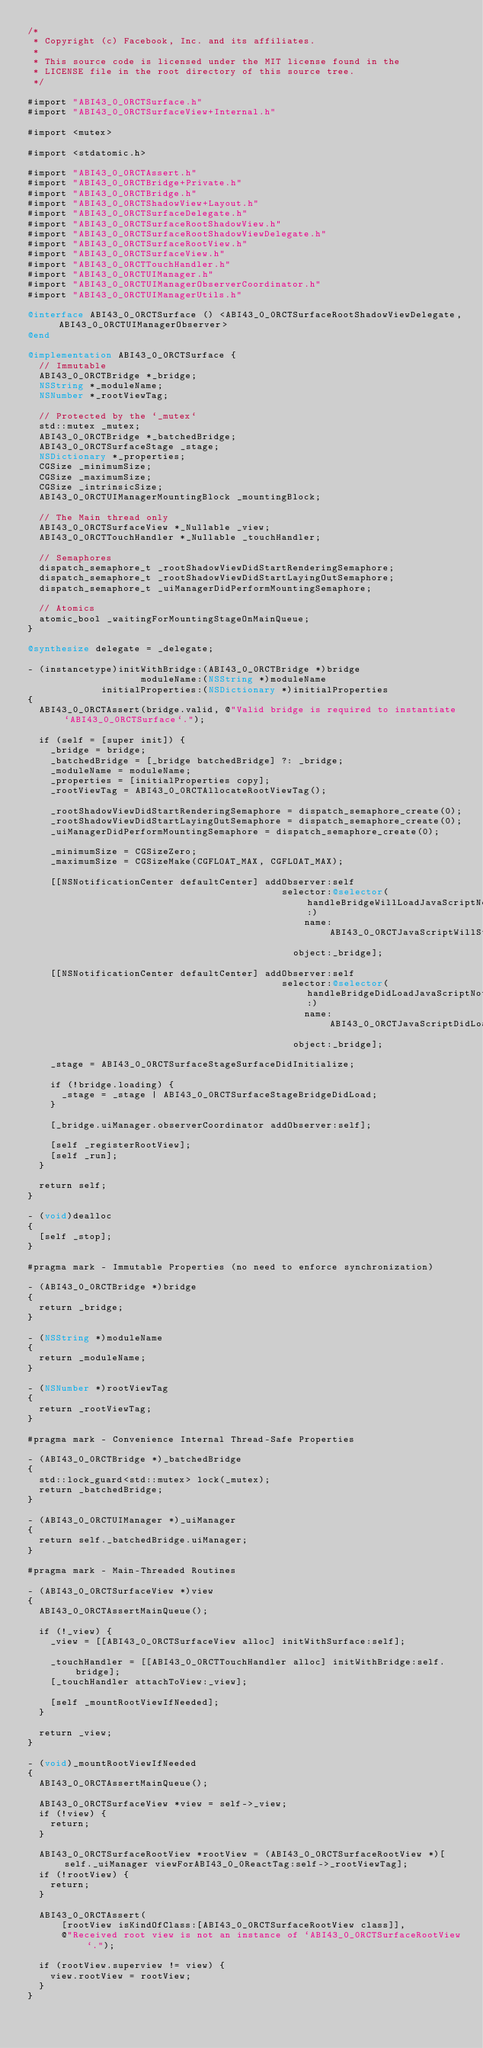Convert code to text. <code><loc_0><loc_0><loc_500><loc_500><_ObjectiveC_>/*
 * Copyright (c) Facebook, Inc. and its affiliates.
 *
 * This source code is licensed under the MIT license found in the
 * LICENSE file in the root directory of this source tree.
 */

#import "ABI43_0_0RCTSurface.h"
#import "ABI43_0_0RCTSurfaceView+Internal.h"

#import <mutex>

#import <stdatomic.h>

#import "ABI43_0_0RCTAssert.h"
#import "ABI43_0_0RCTBridge+Private.h"
#import "ABI43_0_0RCTBridge.h"
#import "ABI43_0_0RCTShadowView+Layout.h"
#import "ABI43_0_0RCTSurfaceDelegate.h"
#import "ABI43_0_0RCTSurfaceRootShadowView.h"
#import "ABI43_0_0RCTSurfaceRootShadowViewDelegate.h"
#import "ABI43_0_0RCTSurfaceRootView.h"
#import "ABI43_0_0RCTSurfaceView.h"
#import "ABI43_0_0RCTTouchHandler.h"
#import "ABI43_0_0RCTUIManager.h"
#import "ABI43_0_0RCTUIManagerObserverCoordinator.h"
#import "ABI43_0_0RCTUIManagerUtils.h"

@interface ABI43_0_0RCTSurface () <ABI43_0_0RCTSurfaceRootShadowViewDelegate, ABI43_0_0RCTUIManagerObserver>
@end

@implementation ABI43_0_0RCTSurface {
  // Immutable
  ABI43_0_0RCTBridge *_bridge;
  NSString *_moduleName;
  NSNumber *_rootViewTag;

  // Protected by the `_mutex`
  std::mutex _mutex;
  ABI43_0_0RCTBridge *_batchedBridge;
  ABI43_0_0RCTSurfaceStage _stage;
  NSDictionary *_properties;
  CGSize _minimumSize;
  CGSize _maximumSize;
  CGSize _intrinsicSize;
  ABI43_0_0RCTUIManagerMountingBlock _mountingBlock;

  // The Main thread only
  ABI43_0_0RCTSurfaceView *_Nullable _view;
  ABI43_0_0RCTTouchHandler *_Nullable _touchHandler;

  // Semaphores
  dispatch_semaphore_t _rootShadowViewDidStartRenderingSemaphore;
  dispatch_semaphore_t _rootShadowViewDidStartLayingOutSemaphore;
  dispatch_semaphore_t _uiManagerDidPerformMountingSemaphore;

  // Atomics
  atomic_bool _waitingForMountingStageOnMainQueue;
}

@synthesize delegate = _delegate;

- (instancetype)initWithBridge:(ABI43_0_0RCTBridge *)bridge
                    moduleName:(NSString *)moduleName
             initialProperties:(NSDictionary *)initialProperties
{
  ABI43_0_0RCTAssert(bridge.valid, @"Valid bridge is required to instantiate `ABI43_0_0RCTSurface`.");

  if (self = [super init]) {
    _bridge = bridge;
    _batchedBridge = [_bridge batchedBridge] ?: _bridge;
    _moduleName = moduleName;
    _properties = [initialProperties copy];
    _rootViewTag = ABI43_0_0RCTAllocateRootViewTag();

    _rootShadowViewDidStartRenderingSemaphore = dispatch_semaphore_create(0);
    _rootShadowViewDidStartLayingOutSemaphore = dispatch_semaphore_create(0);
    _uiManagerDidPerformMountingSemaphore = dispatch_semaphore_create(0);

    _minimumSize = CGSizeZero;
    _maximumSize = CGSizeMake(CGFLOAT_MAX, CGFLOAT_MAX);

    [[NSNotificationCenter defaultCenter] addObserver:self
                                             selector:@selector(handleBridgeWillLoadJavaScriptNotification:)
                                                 name:ABI43_0_0RCTJavaScriptWillStartLoadingNotification
                                               object:_bridge];

    [[NSNotificationCenter defaultCenter] addObserver:self
                                             selector:@selector(handleBridgeDidLoadJavaScriptNotification:)
                                                 name:ABI43_0_0RCTJavaScriptDidLoadNotification
                                               object:_bridge];

    _stage = ABI43_0_0RCTSurfaceStageSurfaceDidInitialize;

    if (!bridge.loading) {
      _stage = _stage | ABI43_0_0RCTSurfaceStageBridgeDidLoad;
    }

    [_bridge.uiManager.observerCoordinator addObserver:self];

    [self _registerRootView];
    [self _run];
  }

  return self;
}

- (void)dealloc
{
  [self _stop];
}

#pragma mark - Immutable Properties (no need to enforce synchronization)

- (ABI43_0_0RCTBridge *)bridge
{
  return _bridge;
}

- (NSString *)moduleName
{
  return _moduleName;
}

- (NSNumber *)rootViewTag
{
  return _rootViewTag;
}

#pragma mark - Convenience Internal Thread-Safe Properties

- (ABI43_0_0RCTBridge *)_batchedBridge
{
  std::lock_guard<std::mutex> lock(_mutex);
  return _batchedBridge;
}

- (ABI43_0_0RCTUIManager *)_uiManager
{
  return self._batchedBridge.uiManager;
}

#pragma mark - Main-Threaded Routines

- (ABI43_0_0RCTSurfaceView *)view
{
  ABI43_0_0RCTAssertMainQueue();

  if (!_view) {
    _view = [[ABI43_0_0RCTSurfaceView alloc] initWithSurface:self];

    _touchHandler = [[ABI43_0_0RCTTouchHandler alloc] initWithBridge:self.bridge];
    [_touchHandler attachToView:_view];

    [self _mountRootViewIfNeeded];
  }

  return _view;
}

- (void)_mountRootViewIfNeeded
{
  ABI43_0_0RCTAssertMainQueue();

  ABI43_0_0RCTSurfaceView *view = self->_view;
  if (!view) {
    return;
  }

  ABI43_0_0RCTSurfaceRootView *rootView = (ABI43_0_0RCTSurfaceRootView *)[self._uiManager viewForABI43_0_0ReactTag:self->_rootViewTag];
  if (!rootView) {
    return;
  }

  ABI43_0_0RCTAssert(
      [rootView isKindOfClass:[ABI43_0_0RCTSurfaceRootView class]],
      @"Received root view is not an instance of `ABI43_0_0RCTSurfaceRootView`.");

  if (rootView.superview != view) {
    view.rootView = rootView;
  }
}
</code> 